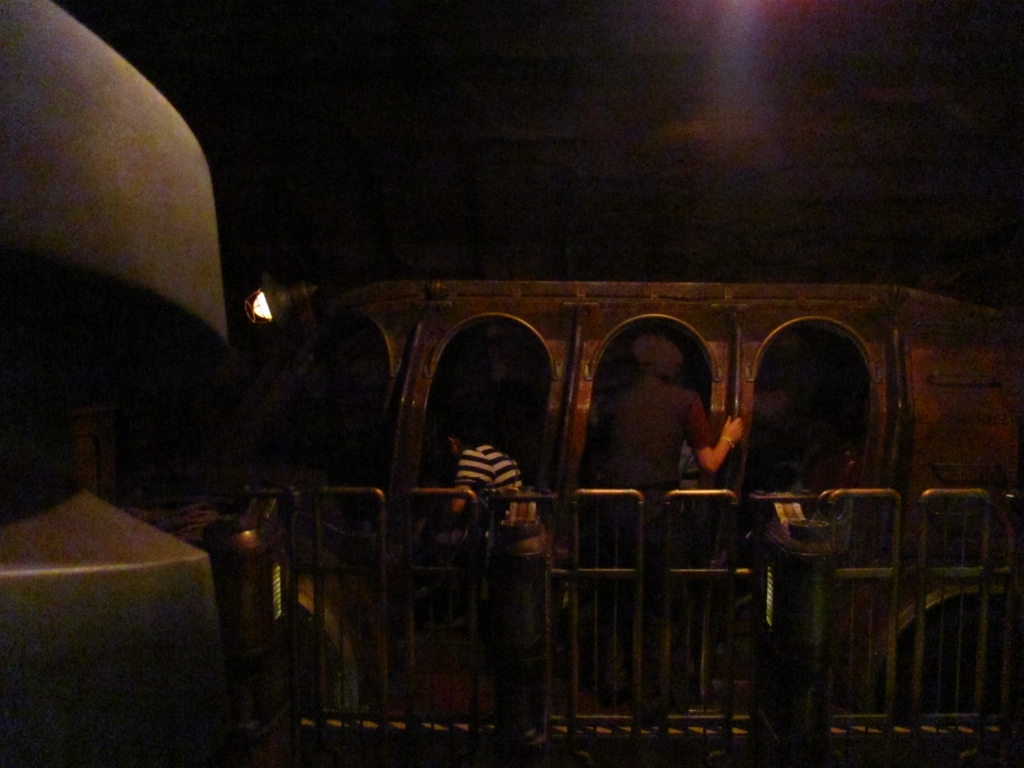What can you say about the clarity of this image? The image is quite dark and the details are not easily discernible. It appears to be taken in low-light conditions without a flash, leading to a lack of sharpness and visible details. Enhancing the brightness and contrast could improve its clarity and reveal more information about the subjects and setting. 